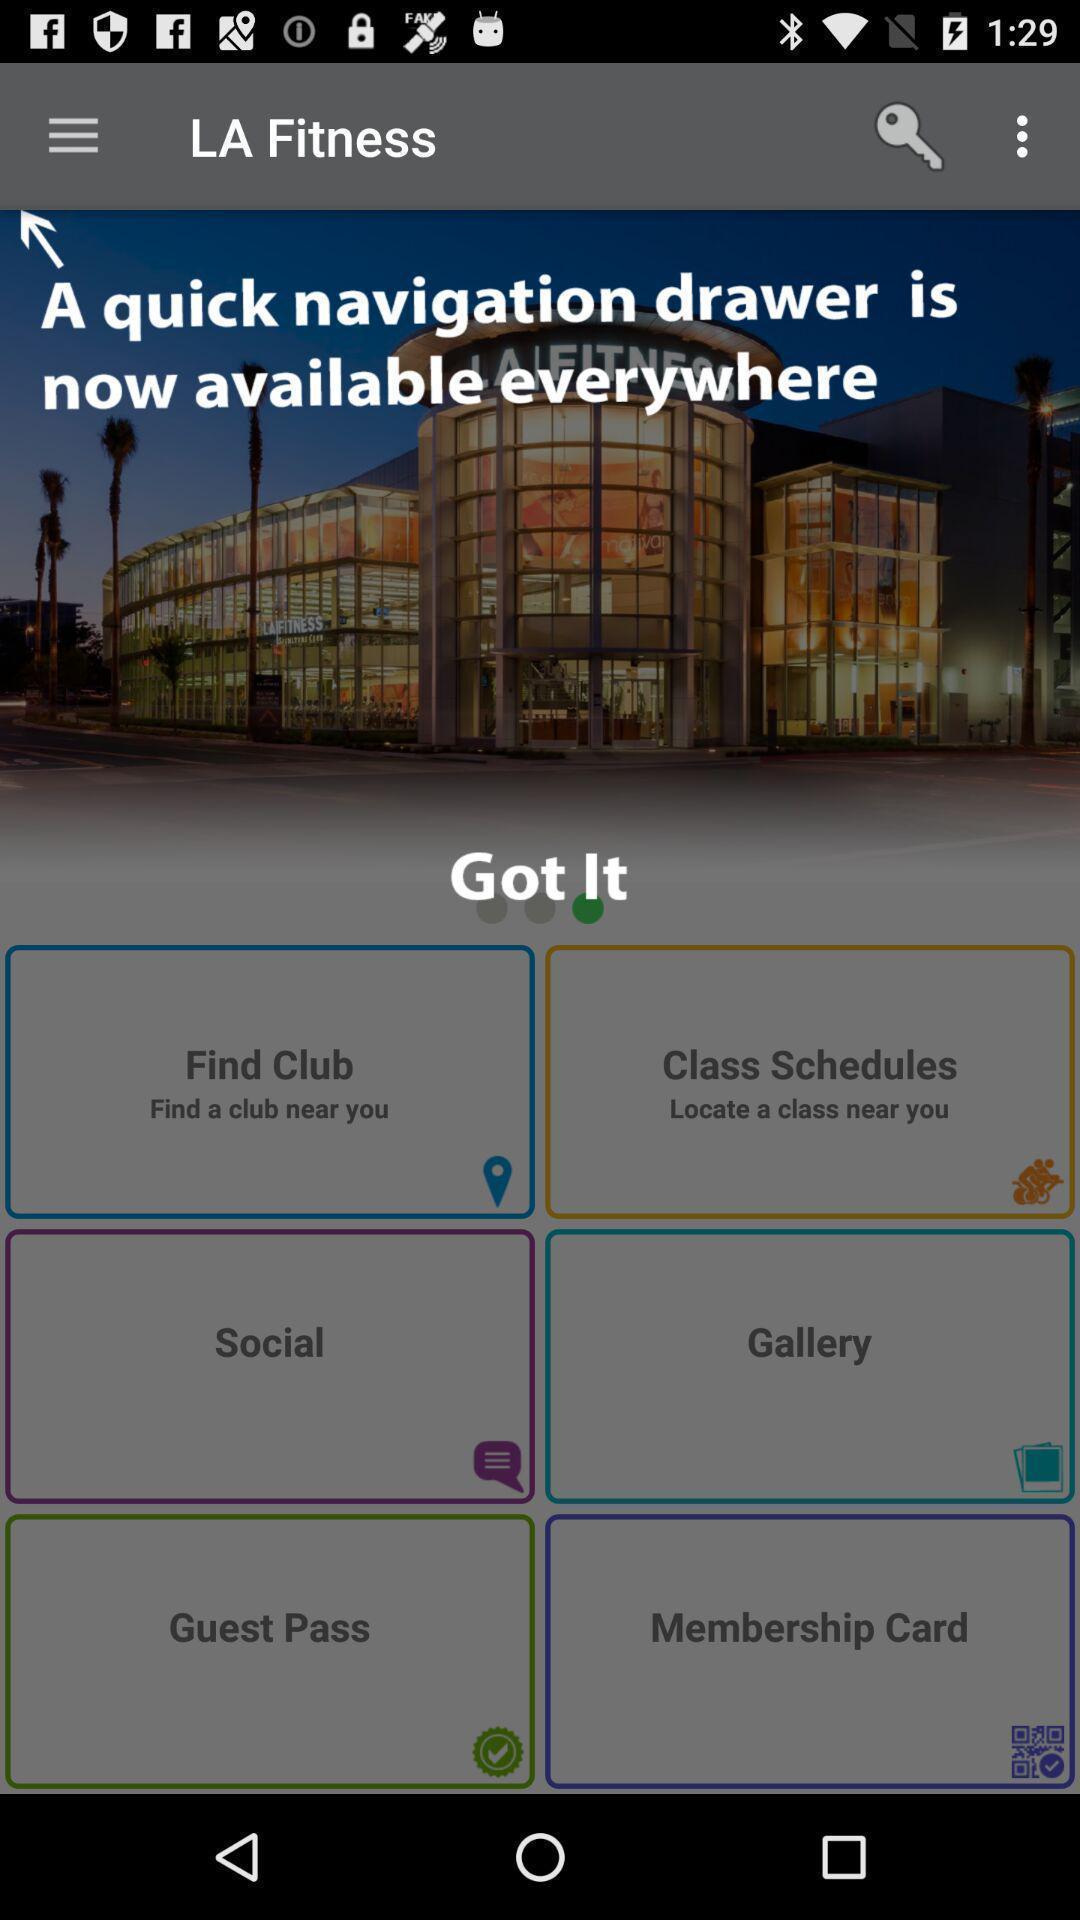What is the overall content of this screenshot? Popup of the information in the fitness app. 